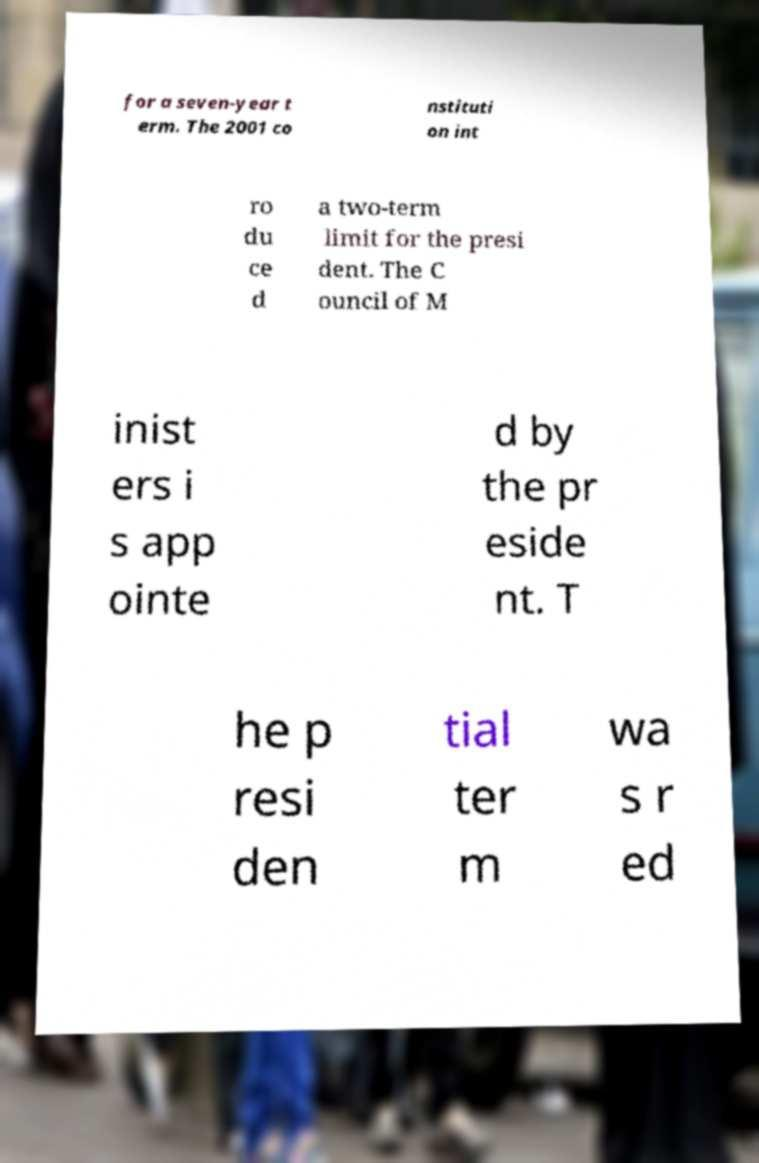Could you assist in decoding the text presented in this image and type it out clearly? for a seven-year t erm. The 2001 co nstituti on int ro du ce d a two-term limit for the presi dent. The C ouncil of M inist ers i s app ointe d by the pr eside nt. T he p resi den tial ter m wa s r ed 